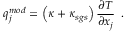<formula> <loc_0><loc_0><loc_500><loc_500>{ q } _ { j } ^ { m o d } = \left ( \kappa + { \kappa } _ { s g s } \right ) \frac { \partial T } { \partial x _ { j } } \, .</formula> 